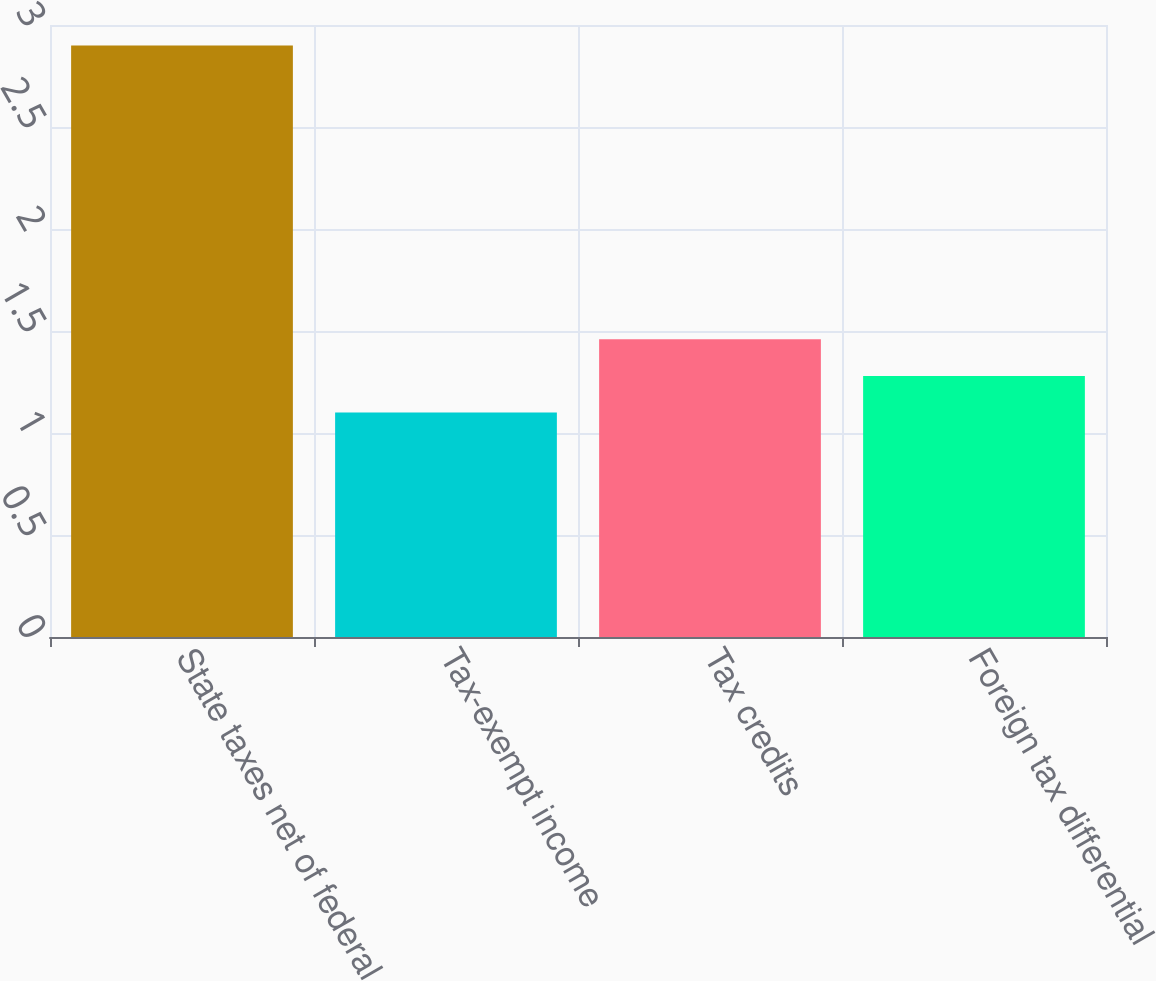Convert chart to OTSL. <chart><loc_0><loc_0><loc_500><loc_500><bar_chart><fcel>State taxes net of federal<fcel>Tax-exempt income<fcel>Tax credits<fcel>Foreign tax differential<nl><fcel>2.9<fcel>1.1<fcel>1.46<fcel>1.28<nl></chart> 